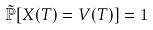Convert formula to latex. <formula><loc_0><loc_0><loc_500><loc_500>\tilde { \mathbb { P } } [ X ( T ) = V ( T ) ] = 1</formula> 